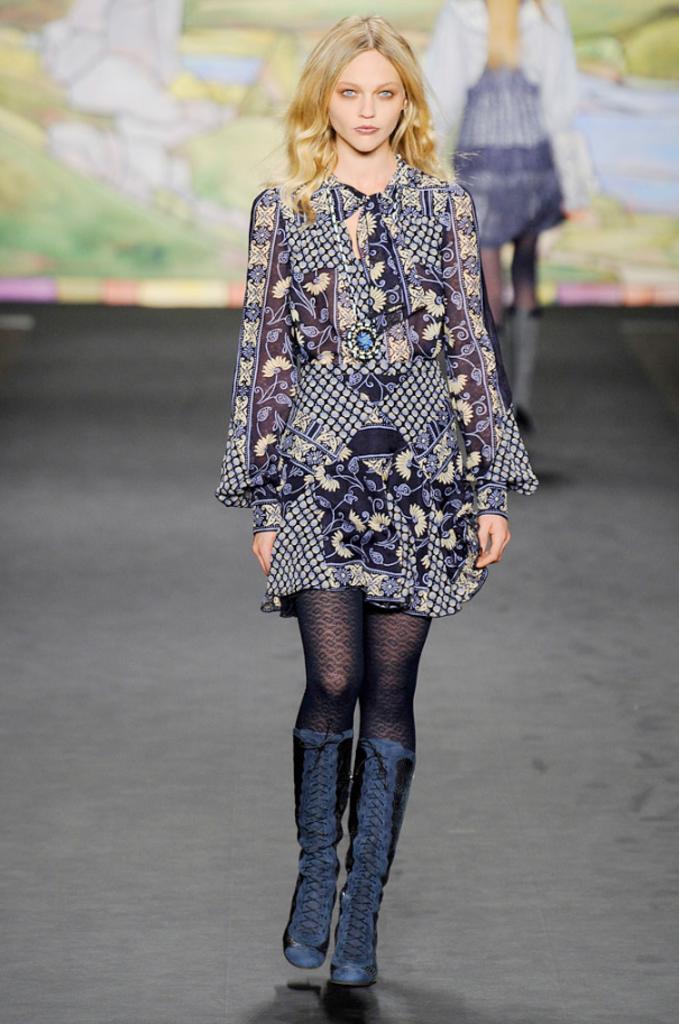How would you summarize this image in a sentence or two? In this image there is a girl who is doing the ramp walk on the stage. In the background there is another girl standing on the stage. Behind her there is a screen. 